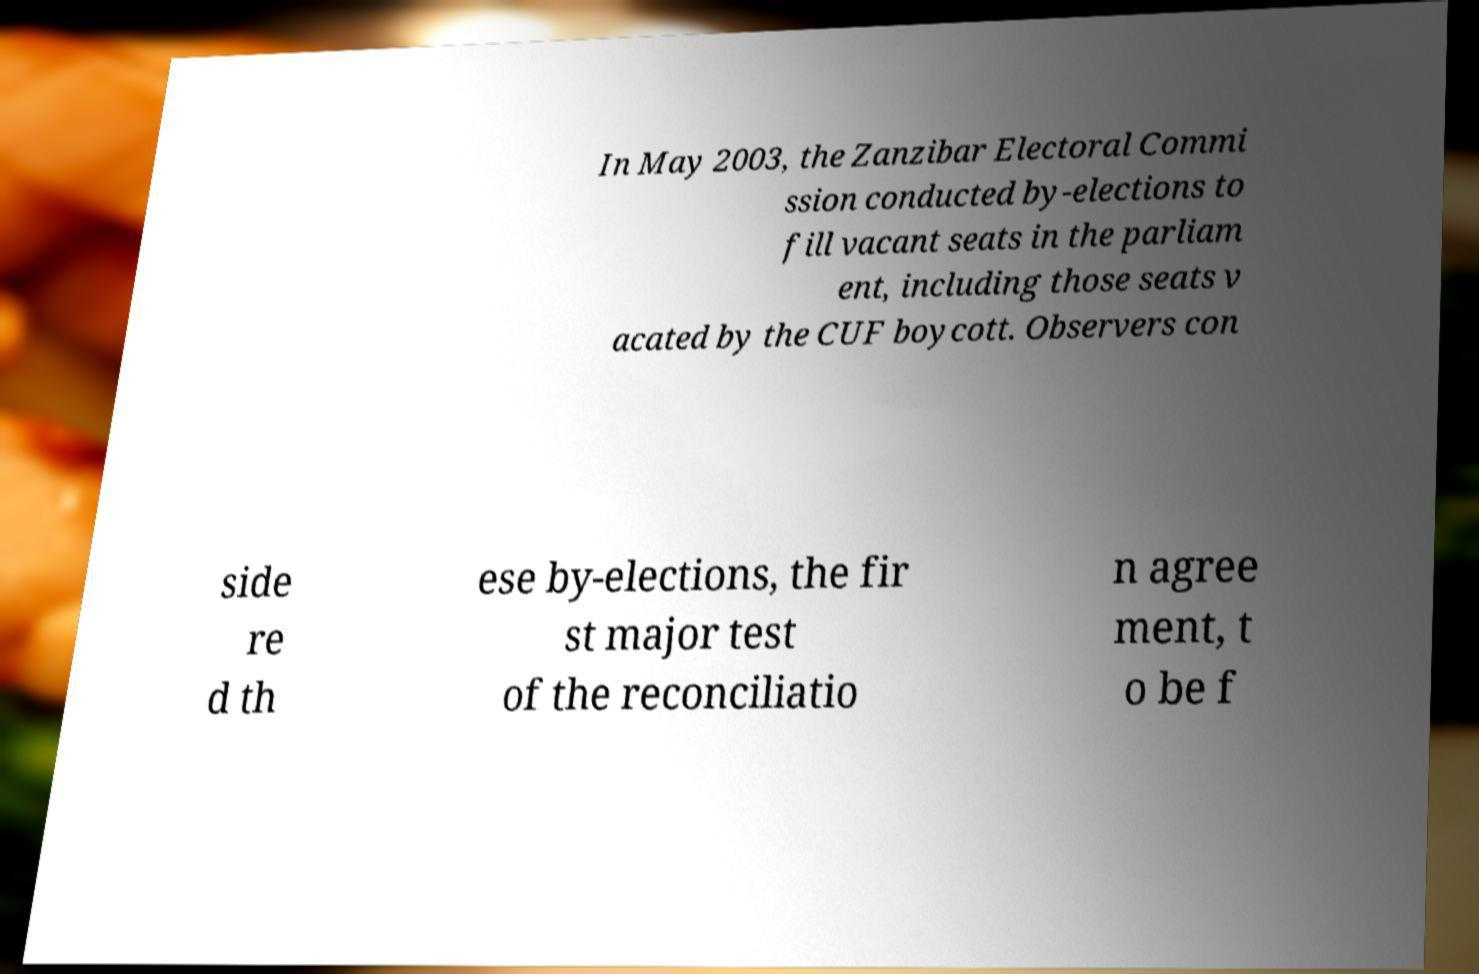Could you extract and type out the text from this image? In May 2003, the Zanzibar Electoral Commi ssion conducted by-elections to fill vacant seats in the parliam ent, including those seats v acated by the CUF boycott. Observers con side re d th ese by-elections, the fir st major test of the reconciliatio n agree ment, t o be f 